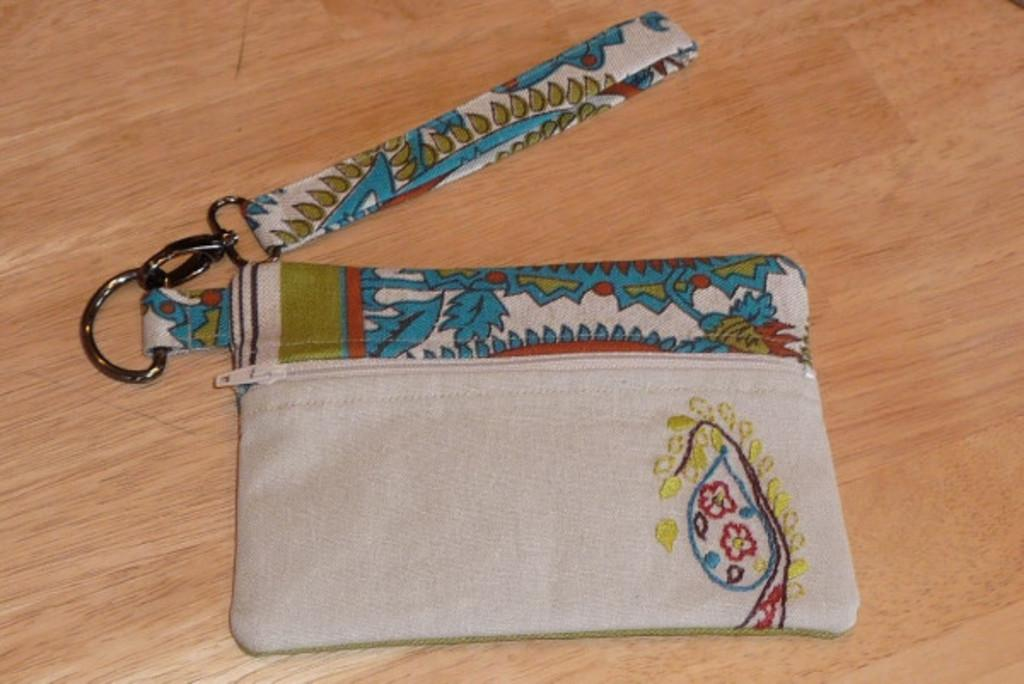What object is present in the image that can be used for carrying items? There is a bag in the image that can be used for carrying items. How is the bag decorated? The bag has a design made with a thread. Where is the bag located in the image? The bag is on a table. How many pizzas are on the table next to the bag? There is no pizza or any reference to a pizza in the image. The image only shows a bag on a table. 